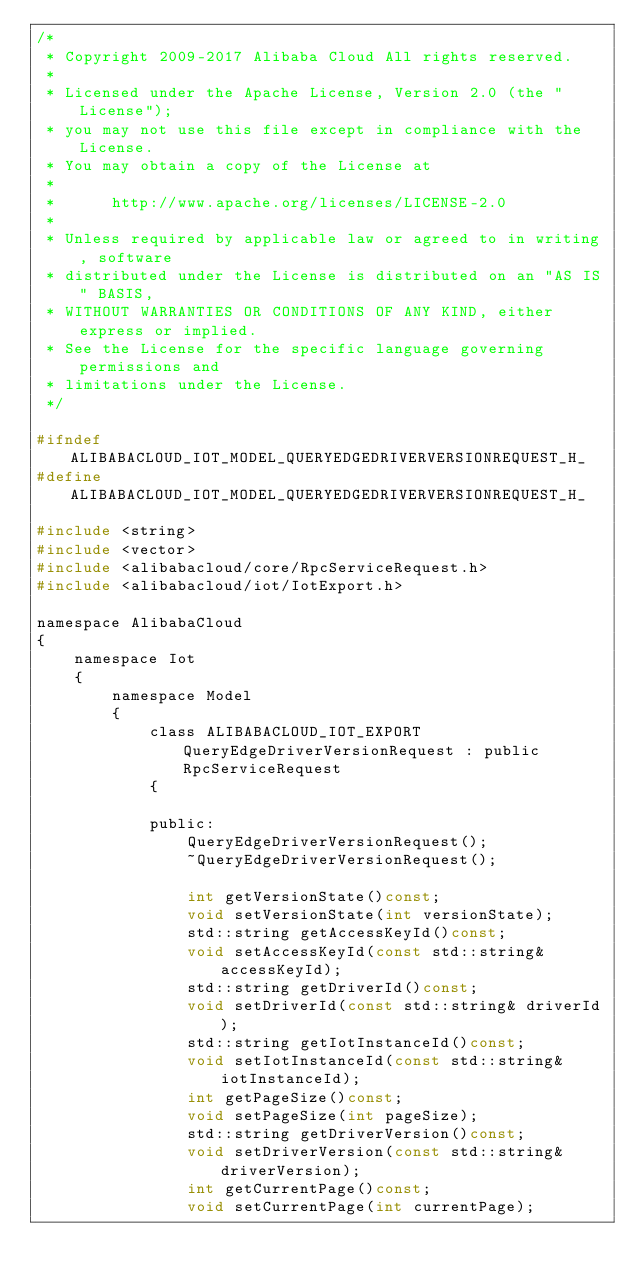Convert code to text. <code><loc_0><loc_0><loc_500><loc_500><_C_>/*
 * Copyright 2009-2017 Alibaba Cloud All rights reserved.
 * 
 * Licensed under the Apache License, Version 2.0 (the "License");
 * you may not use this file except in compliance with the License.
 * You may obtain a copy of the License at
 * 
 *      http://www.apache.org/licenses/LICENSE-2.0
 * 
 * Unless required by applicable law or agreed to in writing, software
 * distributed under the License is distributed on an "AS IS" BASIS,
 * WITHOUT WARRANTIES OR CONDITIONS OF ANY KIND, either express or implied.
 * See the License for the specific language governing permissions and
 * limitations under the License.
 */

#ifndef ALIBABACLOUD_IOT_MODEL_QUERYEDGEDRIVERVERSIONREQUEST_H_
#define ALIBABACLOUD_IOT_MODEL_QUERYEDGEDRIVERVERSIONREQUEST_H_

#include <string>
#include <vector>
#include <alibabacloud/core/RpcServiceRequest.h>
#include <alibabacloud/iot/IotExport.h>

namespace AlibabaCloud
{
	namespace Iot
	{
		namespace Model
		{
			class ALIBABACLOUD_IOT_EXPORT QueryEdgeDriverVersionRequest : public RpcServiceRequest
			{

			public:
				QueryEdgeDriverVersionRequest();
				~QueryEdgeDriverVersionRequest();

				int getVersionState()const;
				void setVersionState(int versionState);
				std::string getAccessKeyId()const;
				void setAccessKeyId(const std::string& accessKeyId);
				std::string getDriverId()const;
				void setDriverId(const std::string& driverId);
				std::string getIotInstanceId()const;
				void setIotInstanceId(const std::string& iotInstanceId);
				int getPageSize()const;
				void setPageSize(int pageSize);
				std::string getDriverVersion()const;
				void setDriverVersion(const std::string& driverVersion);
				int getCurrentPage()const;
				void setCurrentPage(int currentPage);</code> 